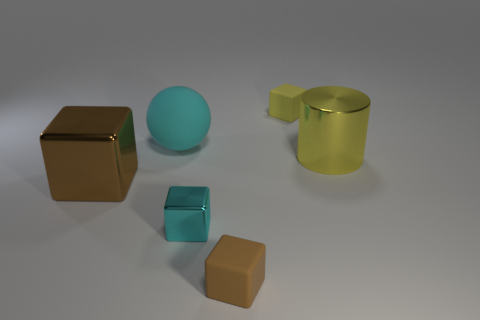Add 3 large green rubber cylinders. How many objects exist? 9 Subtract all cubes. How many objects are left? 2 Subtract 0 gray cubes. How many objects are left? 6 Subtract all tiny green shiny objects. Subtract all small yellow matte cubes. How many objects are left? 5 Add 5 big cylinders. How many big cylinders are left? 6 Add 5 large purple matte objects. How many large purple matte objects exist? 5 